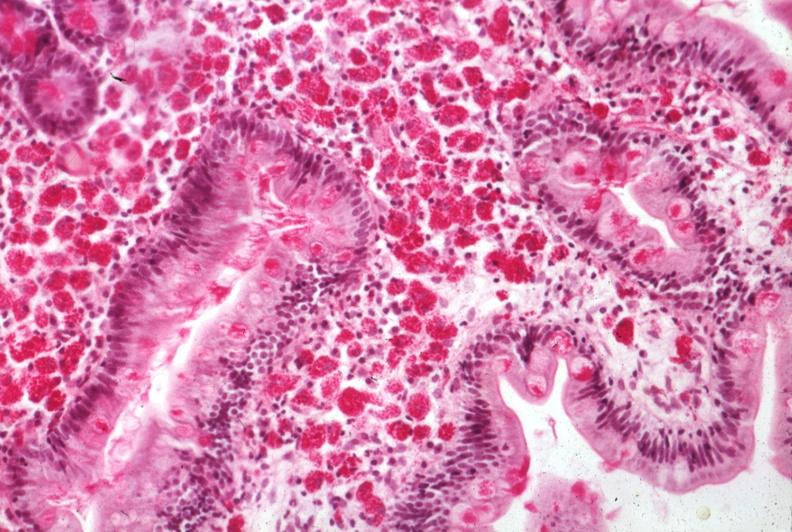where is this from?
Answer the question using a single word or phrase. Gastrointestinal system 